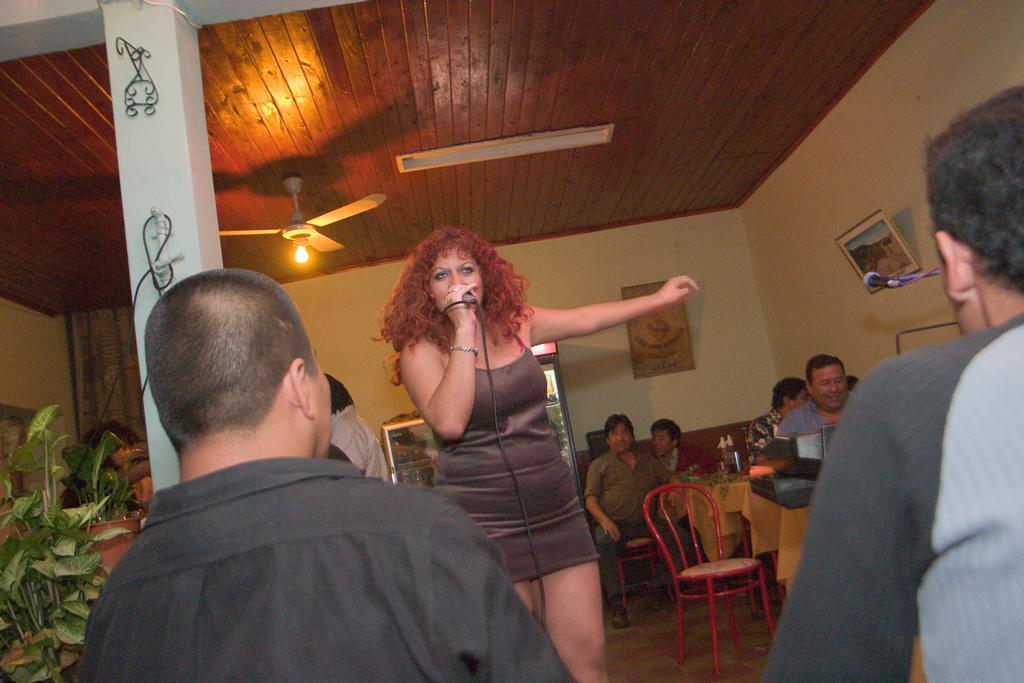In one or two sentences, can you explain what this image depicts? In this picture we can see a woman is holding a microphone. In front of the women there are two men. Behind the woman there is a chair, tables and there are groups of people. There are photo frames on the wall. At the top there is a ceiling fan and a light. On the left side of the image there are plants and a pot. On the right side of the image there is another microphone. 